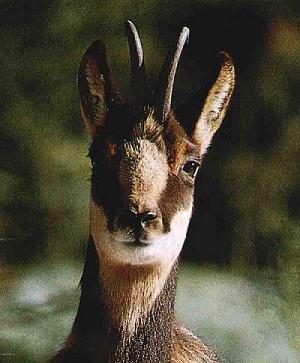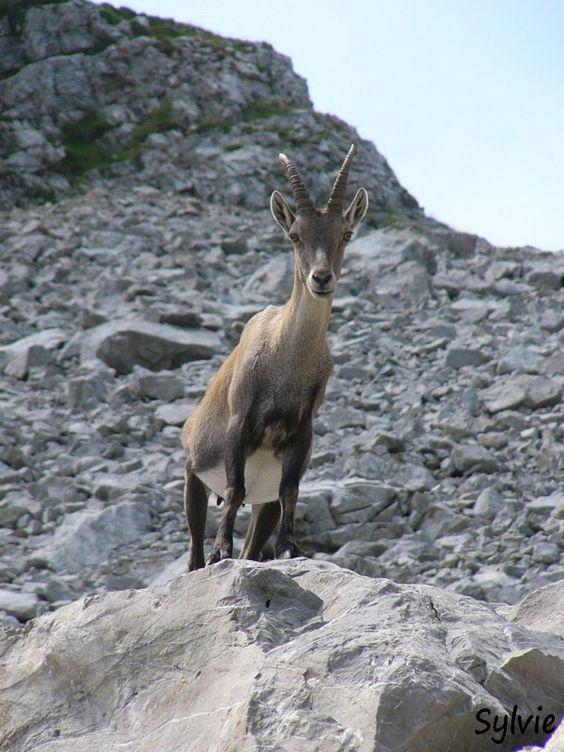The first image is the image on the left, the second image is the image on the right. Examine the images to the left and right. Is the description "There is at least 1 goat standing among plants." accurate? Answer yes or no. No. The first image is the image on the left, the second image is the image on the right. Considering the images on both sides, is "At least one animal with large upright horns on its head is in a snowy area." valid? Answer yes or no. No. 